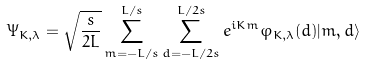<formula> <loc_0><loc_0><loc_500><loc_500>\Psi _ { K , \lambda } = \sqrt { \frac { s } { 2 L } } \sum _ { m = - L / s } ^ { L / s } \sum _ { d = - L / 2 s } ^ { L / 2 s } e ^ { i K m } \varphi _ { K , \lambda } ( d ) | m , d \rangle</formula> 